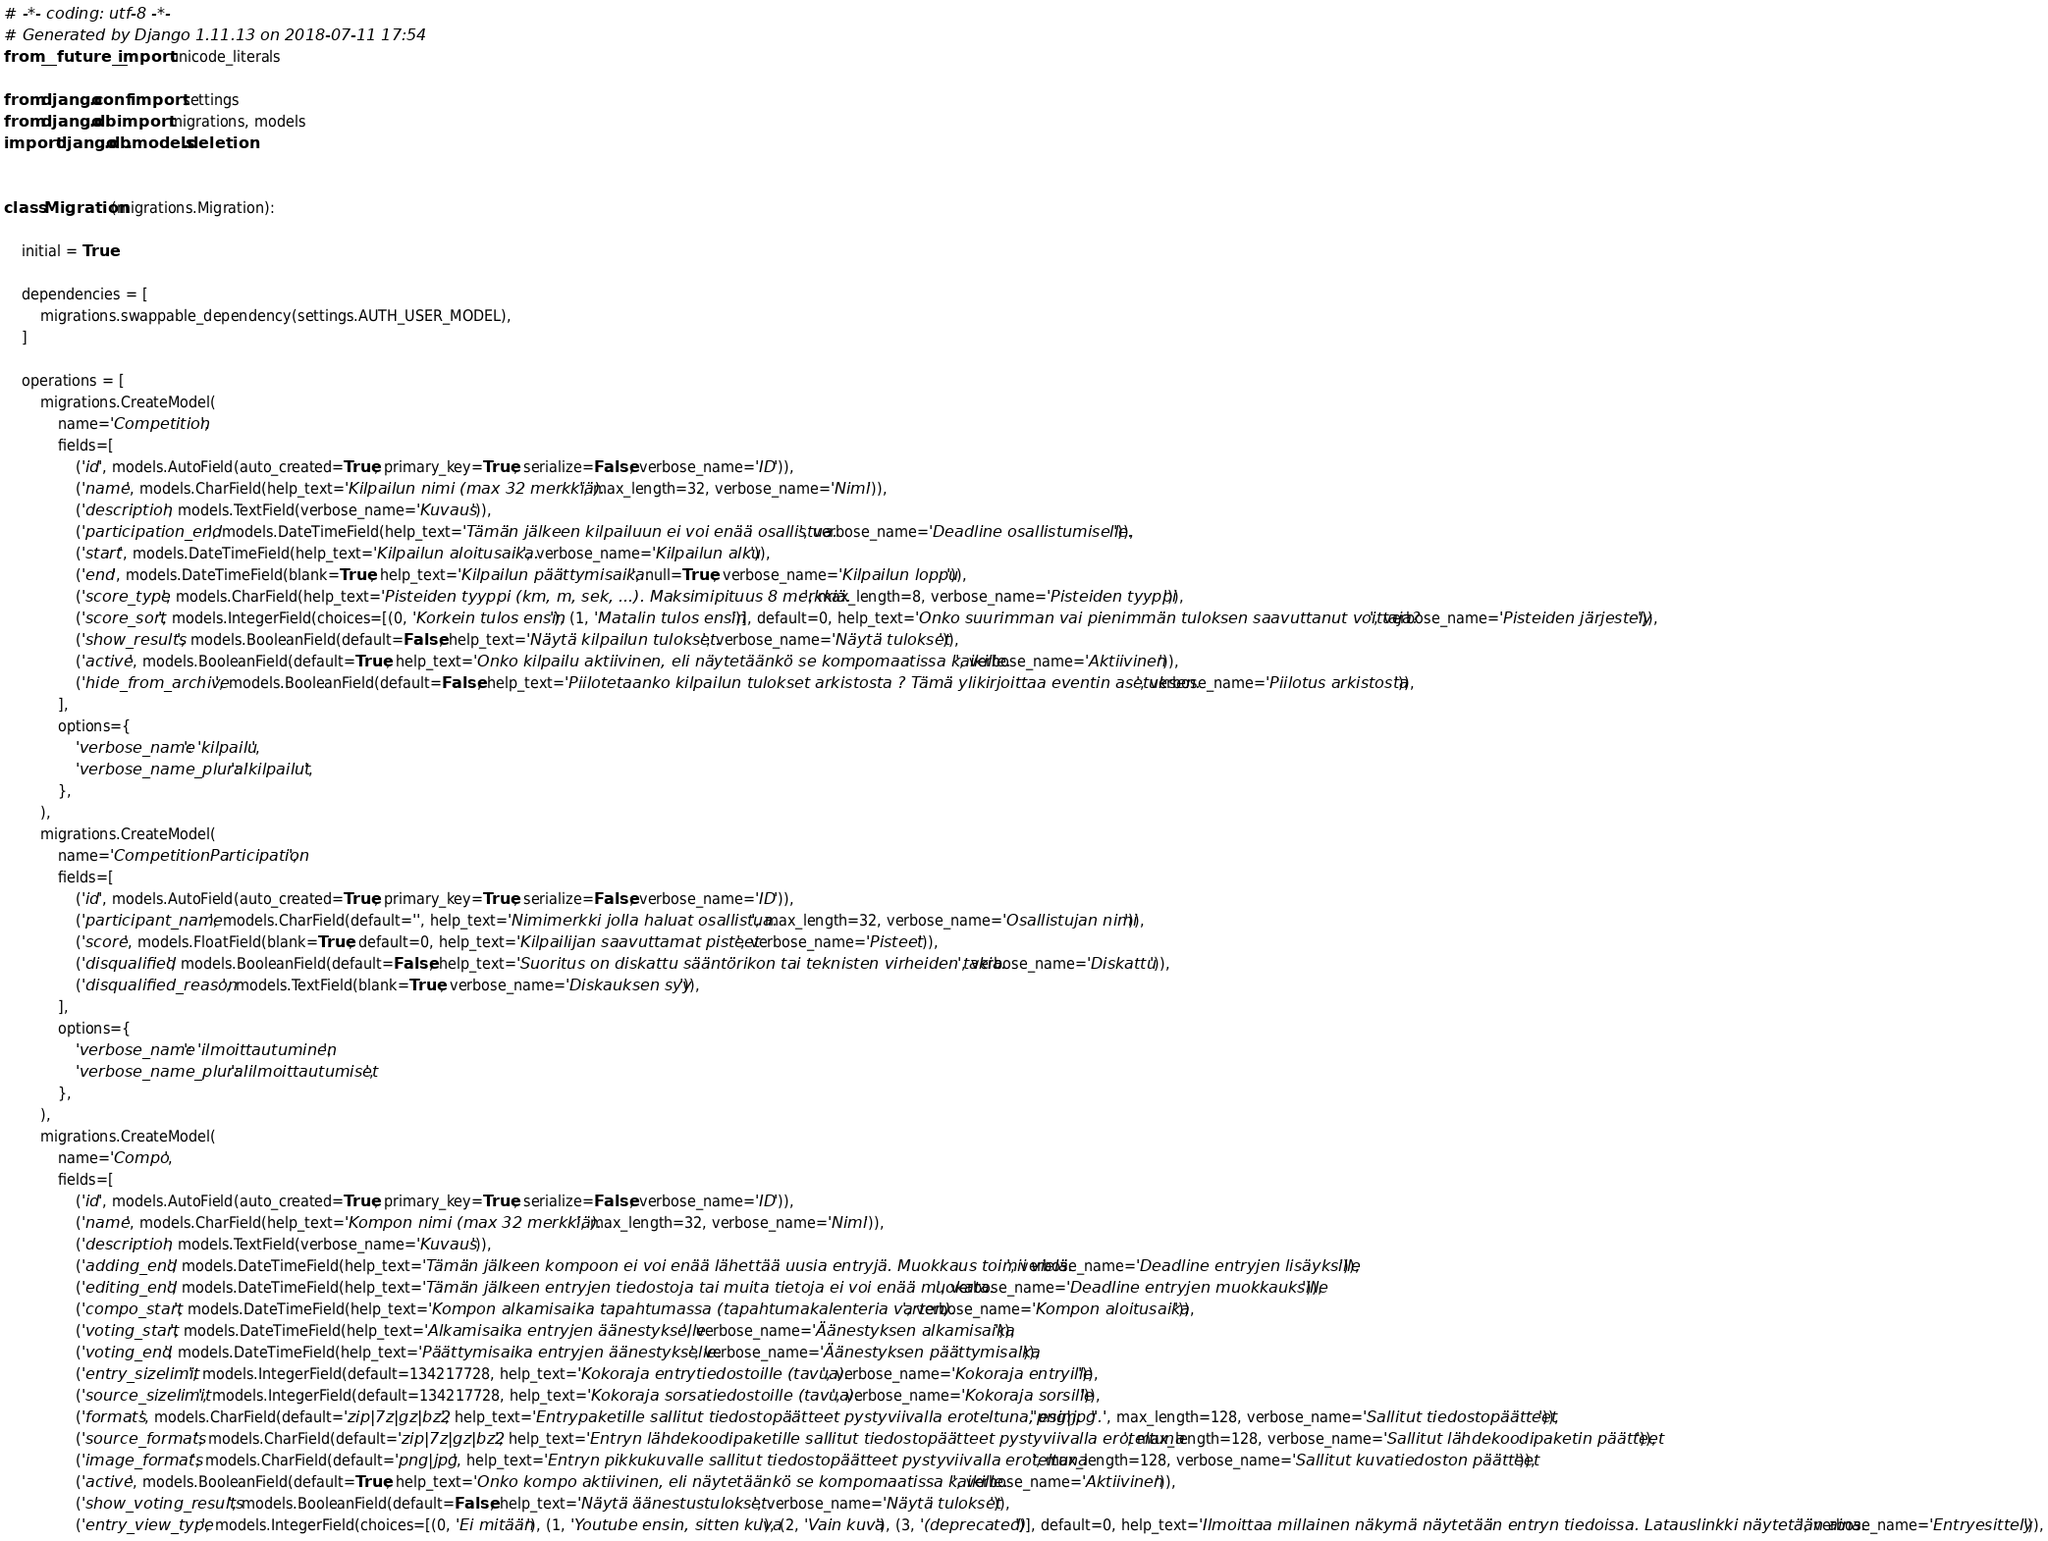<code> <loc_0><loc_0><loc_500><loc_500><_Python_># -*- coding: utf-8 -*-
# Generated by Django 1.11.13 on 2018-07-11 17:54
from __future__ import unicode_literals

from django.conf import settings
from django.db import migrations, models
import django.db.models.deletion


class Migration(migrations.Migration):

    initial = True

    dependencies = [
        migrations.swappable_dependency(settings.AUTH_USER_MODEL),
    ]

    operations = [
        migrations.CreateModel(
            name='Competition',
            fields=[
                ('id', models.AutoField(auto_created=True, primary_key=True, serialize=False, verbose_name='ID')),
                ('name', models.CharField(help_text='Kilpailun nimi (max 32 merkkiä).', max_length=32, verbose_name='Nimi')),
                ('description', models.TextField(verbose_name='Kuvaus')),
                ('participation_end', models.DateTimeField(help_text='Tämän jälkeen kilpailuun ei voi enää osallistua.', verbose_name='Deadline osallistumiselle.')),
                ('start', models.DateTimeField(help_text='Kilpailun aloitusaika.', verbose_name='Kilpailun alku')),
                ('end', models.DateTimeField(blank=True, help_text='Kilpailun päättymisaika.', null=True, verbose_name='Kilpailun loppu')),
                ('score_type', models.CharField(help_text='Pisteiden tyyppi (km, m, sek, ...). Maksimipituus 8 merkkiä.', max_length=8, verbose_name='Pisteiden tyyppi')),
                ('score_sort', models.IntegerField(choices=[(0, 'Korkein tulos ensin'), (1, 'Matalin tulos ensin')], default=0, help_text='Onko suurimman vai pienimmän tuloksen saavuttanut voittaja?', verbose_name='Pisteiden järjestely')),
                ('show_results', models.BooleanField(default=False, help_text='Näytä kilpailun tulokset.', verbose_name='Näytä tulokset')),
                ('active', models.BooleanField(default=True, help_text='Onko kilpailu aktiivinen, eli näytetäänkö se kompomaatissa kaikille.', verbose_name='Aktiivinen')),
                ('hide_from_archive', models.BooleanField(default=False, help_text='Piilotetaanko kilpailun tulokset arkistosta ? Tämä ylikirjoittaa eventin asetuksen.', verbose_name='Piilotus arkistosta')),
            ],
            options={
                'verbose_name': 'kilpailu',
                'verbose_name_plural': 'kilpailut',
            },
        ),
        migrations.CreateModel(
            name='CompetitionParticipation',
            fields=[
                ('id', models.AutoField(auto_created=True, primary_key=True, serialize=False, verbose_name='ID')),
                ('participant_name', models.CharField(default='', help_text='Nimimerkki jolla haluat osallistua.', max_length=32, verbose_name='Osallistujan nimi')),
                ('score', models.FloatField(blank=True, default=0, help_text='Kilpailijan saavuttamat pisteet', verbose_name='Pisteet')),
                ('disqualified', models.BooleanField(default=False, help_text='Suoritus on diskattu sääntörikon tai teknisten virheiden takia.', verbose_name='Diskattu')),
                ('disqualified_reason', models.TextField(blank=True, verbose_name='Diskauksen syy')),
            ],
            options={
                'verbose_name': 'ilmoittautuminen',
                'verbose_name_plural': 'ilmoittautumiset',
            },
        ),
        migrations.CreateModel(
            name='Compo',
            fields=[
                ('id', models.AutoField(auto_created=True, primary_key=True, serialize=False, verbose_name='ID')),
                ('name', models.CharField(help_text='Kompon nimi (max 32 merkkiä).', max_length=32, verbose_name='Nimi')),
                ('description', models.TextField(verbose_name='Kuvaus')),
                ('adding_end', models.DateTimeField(help_text='Tämän jälkeen kompoon ei voi enää lähettää uusia entryjä. Muokkaus toimii vielä.', verbose_name='Deadline entryjen lisäyksille')),
                ('editing_end', models.DateTimeField(help_text='Tämän jälkeen entryjen tiedostoja tai muita tietoja ei voi enää muokata.', verbose_name='Deadline entryjen muokkauksille')),
                ('compo_start', models.DateTimeField(help_text='Kompon alkamisaika tapahtumassa (tapahtumakalenteria varten).', verbose_name='Kompon aloitusaika')),
                ('voting_start', models.DateTimeField(help_text='Alkamisaika entryjen äänestykselle.', verbose_name='Äänestyksen alkamisaika')),
                ('voting_end', models.DateTimeField(help_text='Päättymisaika entryjen äänestykselle.', verbose_name='Äänestyksen päättymisaika')),
                ('entry_sizelimit', models.IntegerField(default=134217728, help_text='Kokoraja entrytiedostoille (tavua).', verbose_name='Kokoraja entryille')),
                ('source_sizelimit', models.IntegerField(default=134217728, help_text='Kokoraja sorsatiedostoille (tavua).', verbose_name='Kokoraja sorsille')),
                ('formats', models.CharField(default='zip|7z|gz|bz2', help_text='Entrypaketille sallitut tiedostopäätteet pystyviivalla eroteltuna, esim. "png|jpg".', max_length=128, verbose_name='Sallitut tiedostopäätteet')),
                ('source_formats', models.CharField(default='zip|7z|gz|bz2', help_text='Entryn lähdekoodipaketille sallitut tiedostopäätteet pystyviivalla eroteltuna', max_length=128, verbose_name='Sallitut lähdekoodipaketin päätteet')),
                ('image_formats', models.CharField(default='png|jpg', help_text='Entryn pikkukuvalle sallitut tiedostopäätteet pystyviivalla eroteltuna', max_length=128, verbose_name='Sallitut kuvatiedoston päätteet')),
                ('active', models.BooleanField(default=True, help_text='Onko kompo aktiivinen, eli näytetäänkö se kompomaatissa kaikille.', verbose_name='Aktiivinen')),
                ('show_voting_results', models.BooleanField(default=False, help_text='Näytä äänestustulokset.', verbose_name='Näytä tulokset')),
                ('entry_view_type', models.IntegerField(choices=[(0, 'Ei mitään'), (1, 'Youtube ensin, sitten kuva'), (2, 'Vain kuva'), (3, '(deprecated)')], default=0, help_text='Ilmoittaa millainen näkymä näytetään entryn tiedoissa. Latauslinkki näytetään aina.', verbose_name='Entryesittely')),</code> 